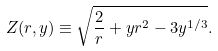<formula> <loc_0><loc_0><loc_500><loc_500>Z ( r , y ) \equiv \sqrt { \frac { 2 } { r } + y r ^ { 2 } - 3 y ^ { 1 / 3 } } .</formula> 